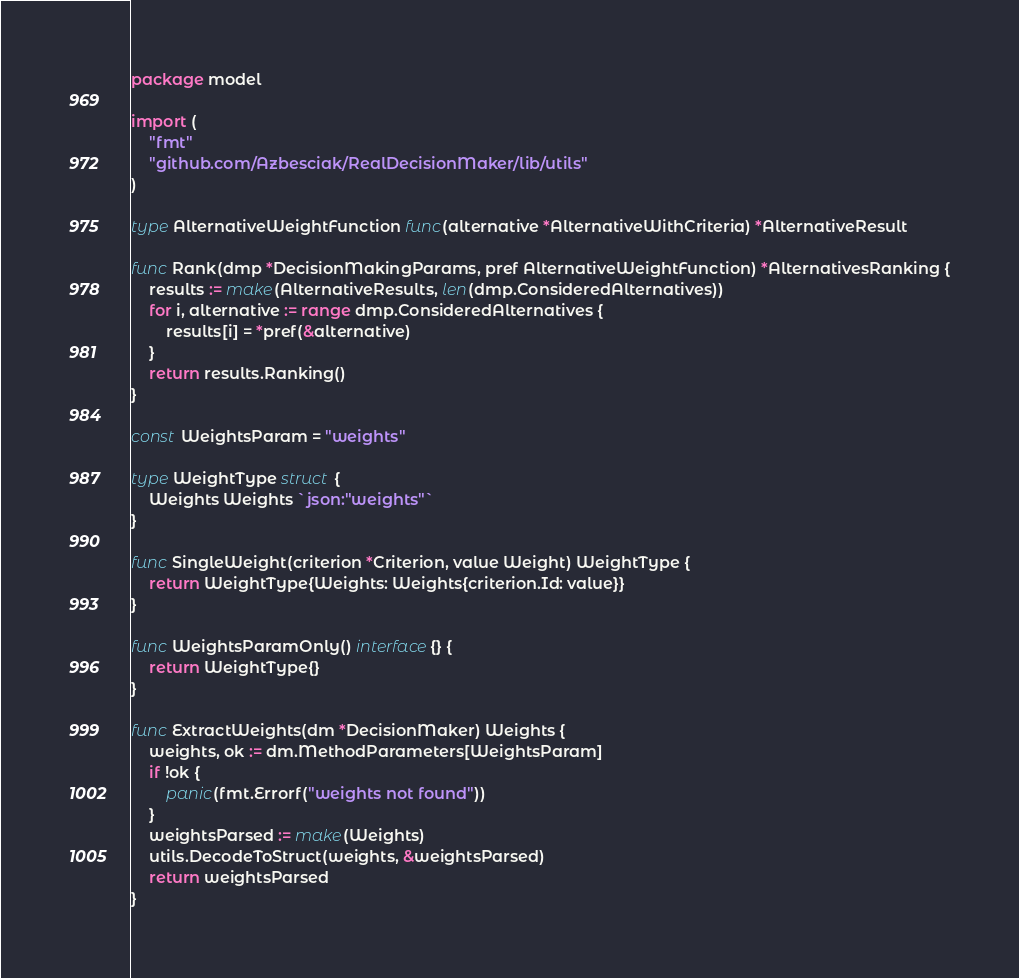Convert code to text. <code><loc_0><loc_0><loc_500><loc_500><_Go_>package model

import (
	"fmt"
	"github.com/Azbesciak/RealDecisionMaker/lib/utils"
)

type AlternativeWeightFunction func(alternative *AlternativeWithCriteria) *AlternativeResult

func Rank(dmp *DecisionMakingParams, pref AlternativeWeightFunction) *AlternativesRanking {
	results := make(AlternativeResults, len(dmp.ConsideredAlternatives))
	for i, alternative := range dmp.ConsideredAlternatives {
		results[i] = *pref(&alternative)
	}
	return results.Ranking()
}

const WeightsParam = "weights"

type WeightType struct {
	Weights Weights `json:"weights"`
}

func SingleWeight(criterion *Criterion, value Weight) WeightType {
	return WeightType{Weights: Weights{criterion.Id: value}}
}

func WeightsParamOnly() interface{} {
	return WeightType{}
}

func ExtractWeights(dm *DecisionMaker) Weights {
	weights, ok := dm.MethodParameters[WeightsParam]
	if !ok {
		panic(fmt.Errorf("weights not found"))
	}
	weightsParsed := make(Weights)
	utils.DecodeToStruct(weights, &weightsParsed)
	return weightsParsed
}
</code> 